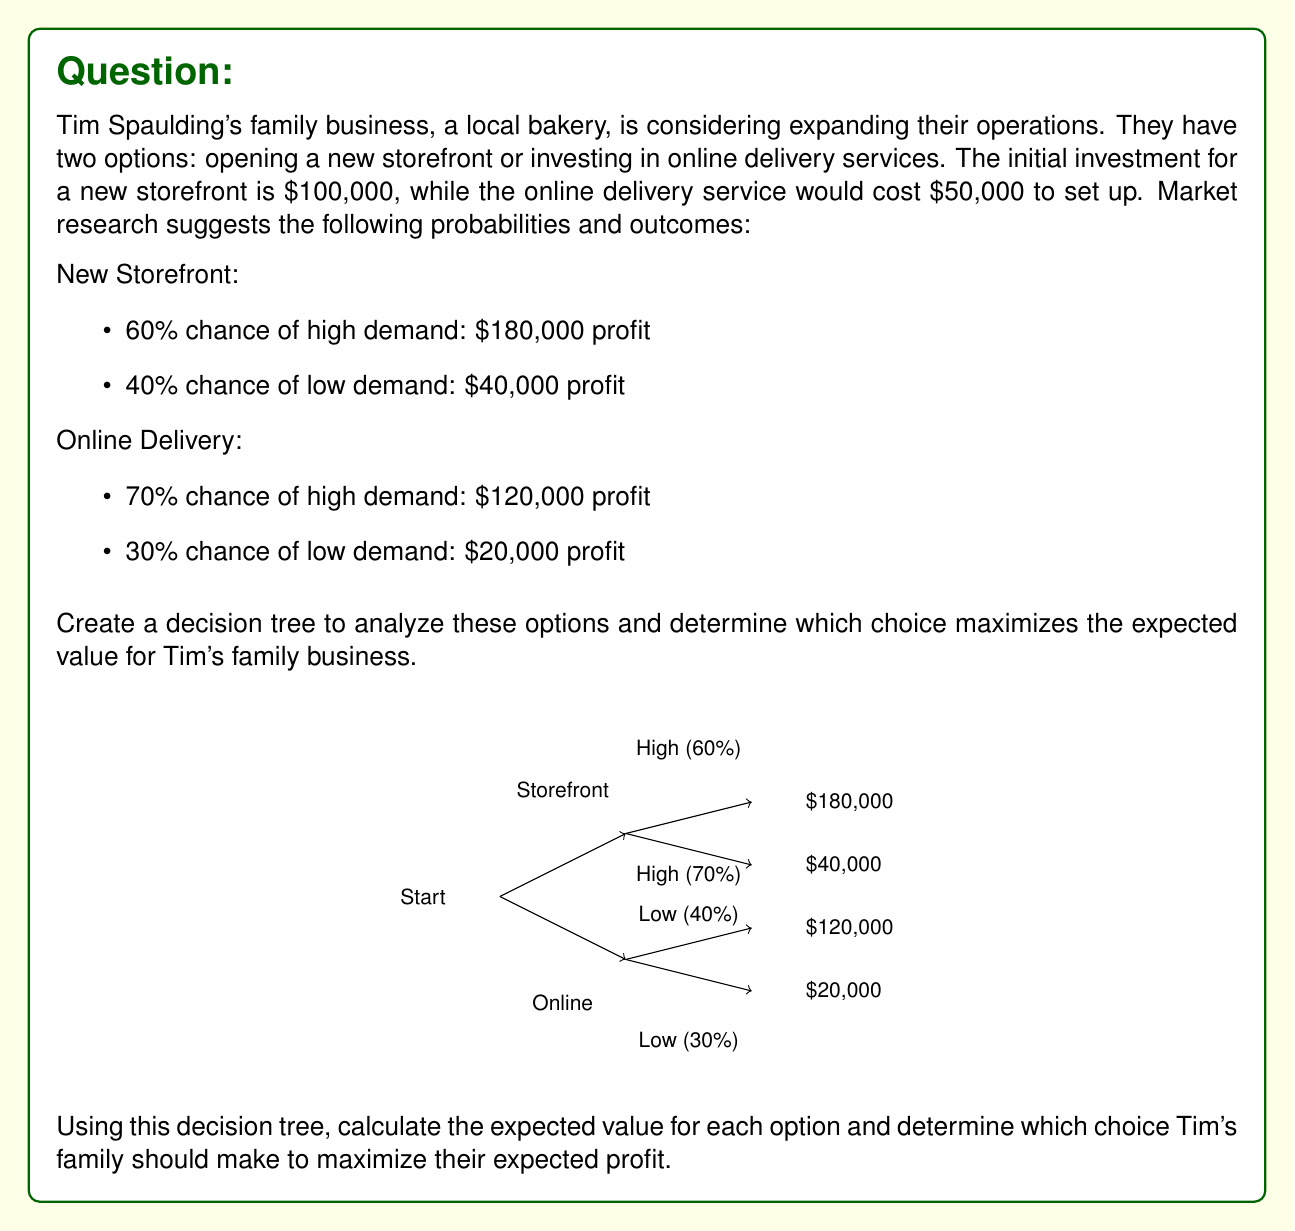Give your solution to this math problem. To solve this problem, we'll calculate the expected value (EV) for each option using the decision tree:

1. Calculate EV for New Storefront:
   $EV_{storefront} = (0.60 \times \$180,000) + (0.40 \times \$40,000) - \$100,000$
   $EV_{storefront} = \$108,000 + \$16,000 - \$100,000 = \$24,000$

2. Calculate EV for Online Delivery:
   $EV_{online} = (0.70 \times \$120,000) + (0.30 \times \$20,000) - \$50,000$
   $EV_{online} = \$84,000 + \$6,000 - \$50,000 = \$40,000$

3. Compare the expected values:
   $EV_{online} > EV_{storefront}$
   $\$40,000 > \$24,000$

The expected value for the online delivery option is higher than the new storefront option.

4. Decision:
   Since the online delivery option has a higher expected value, Tim's family should choose this option to maximize their expected profit.
Answer: Choose online delivery; EV = $40,000 